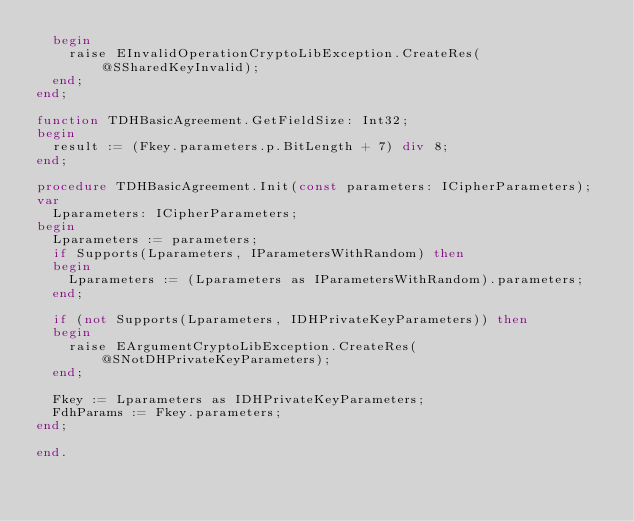Convert code to text. <code><loc_0><loc_0><loc_500><loc_500><_Pascal_>  begin
    raise EInvalidOperationCryptoLibException.CreateRes(@SSharedKeyInvalid);
  end;
end;

function TDHBasicAgreement.GetFieldSize: Int32;
begin
  result := (Fkey.parameters.p.BitLength + 7) div 8;
end;

procedure TDHBasicAgreement.Init(const parameters: ICipherParameters);
var
  Lparameters: ICipherParameters;
begin
  Lparameters := parameters;
  if Supports(Lparameters, IParametersWithRandom) then
  begin
    Lparameters := (Lparameters as IParametersWithRandom).parameters;
  end;

  if (not Supports(Lparameters, IDHPrivateKeyParameters)) then
  begin
    raise EArgumentCryptoLibException.CreateRes(@SNotDHPrivateKeyParameters);
  end;

  Fkey := Lparameters as IDHPrivateKeyParameters;
  FdhParams := Fkey.parameters;
end;

end.
</code> 